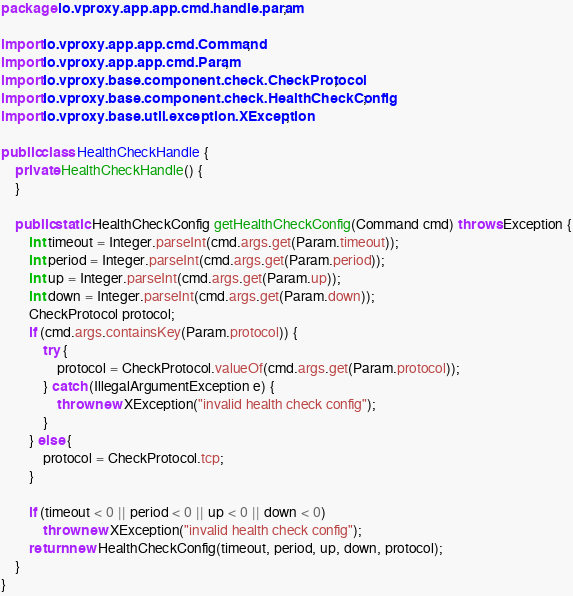<code> <loc_0><loc_0><loc_500><loc_500><_Java_>package io.vproxy.app.app.cmd.handle.param;

import io.vproxy.app.app.cmd.Command;
import io.vproxy.app.app.cmd.Param;
import io.vproxy.base.component.check.CheckProtocol;
import io.vproxy.base.component.check.HealthCheckConfig;
import io.vproxy.base.util.exception.XException;

public class HealthCheckHandle {
    private HealthCheckHandle() {
    }

    public static HealthCheckConfig getHealthCheckConfig(Command cmd) throws Exception {
        int timeout = Integer.parseInt(cmd.args.get(Param.timeout));
        int period = Integer.parseInt(cmd.args.get(Param.period));
        int up = Integer.parseInt(cmd.args.get(Param.up));
        int down = Integer.parseInt(cmd.args.get(Param.down));
        CheckProtocol protocol;
        if (cmd.args.containsKey(Param.protocol)) {
            try {
                protocol = CheckProtocol.valueOf(cmd.args.get(Param.protocol));
            } catch (IllegalArgumentException e) {
                throw new XException("invalid health check config");
            }
        } else {
            protocol = CheckProtocol.tcp;
        }

        if (timeout < 0 || period < 0 || up < 0 || down < 0)
            throw new XException("invalid health check config");
        return new HealthCheckConfig(timeout, period, up, down, protocol);
    }
}
</code> 